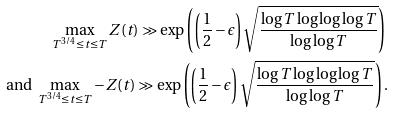Convert formula to latex. <formula><loc_0><loc_0><loc_500><loc_500>& \quad \max _ { T ^ { 3 / 4 } \leq t \leq T } Z ( t ) \gg \exp \left ( \left ( \frac { 1 } { 2 } - \epsilon \right ) \sqrt { \frac { \log T \log \log \log T } { \log \log T } } \right ) \\ \text { and } & \max _ { T ^ { 3 / 4 } \leq t \leq T } - Z ( t ) \gg \exp \left ( \left ( \frac { 1 } { 2 } - \epsilon \right ) \sqrt { \frac { \log T \log \log \log T } { \log \log T } } \right ) .</formula> 